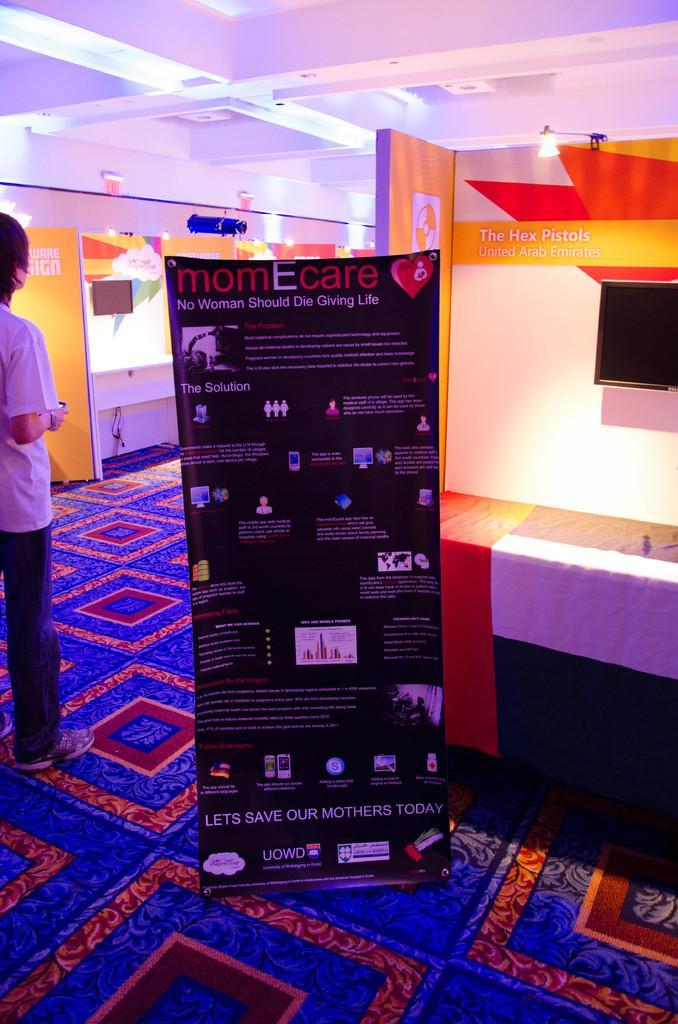Describe this image in one or two sentences. In this image we can see a person standing on the floor, advertisement board, television screen and a carpet. 